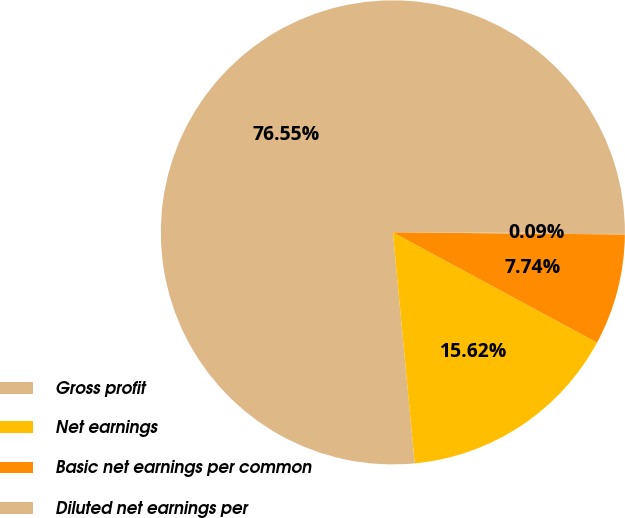Convert chart. <chart><loc_0><loc_0><loc_500><loc_500><pie_chart><fcel>Gross profit<fcel>Net earnings<fcel>Basic net earnings per common<fcel>Diluted net earnings per<nl><fcel>76.56%<fcel>15.62%<fcel>7.74%<fcel>0.09%<nl></chart> 